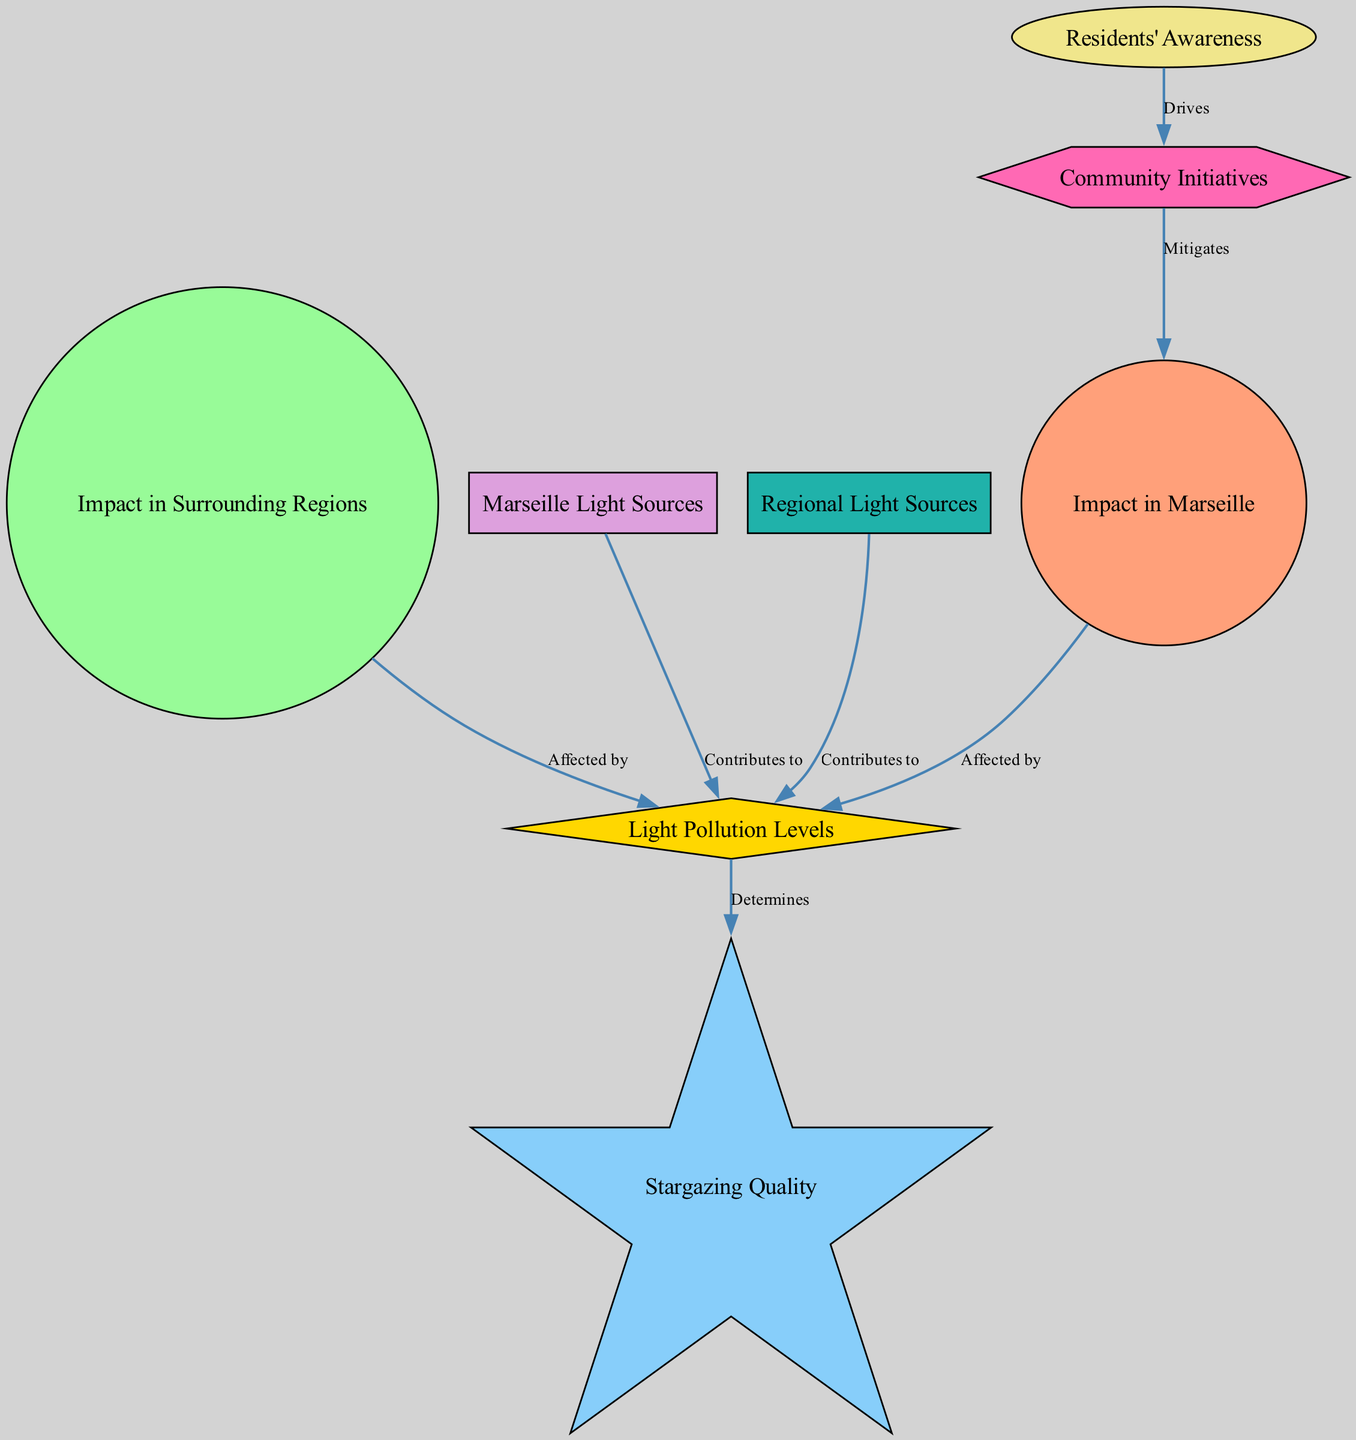What is the main impact of light pollution in Marseille? The diagram indicates that the main impact in Marseille is highlighted in the "Impact in Marseille" node. This node is connected to "Light Pollution Levels" node, indicating that the impact is due to the levels of light pollution present.
Answer: Impact in Marseille Which node signifies the contribution of Marseille's light sources to light pollution? The "Marseille Light Sources" node is connected to the "Light Pollution Levels" node, indicating that these sources contribute to the pollution levels affecting stargazing.
Answer: Marseille Light Sources What type of relationship exists between light pollution levels and stargazing quality? The diagram shows a directed edge from the "Light Pollution Levels" to the "Stargazing Quality" node, indicating a determining relationship where increased pollution negatively affects stargazing quality.
Answer: Determines How many community initiatives are associated with residents' awareness? The "Residents' Awareness" node is connected to the "Community Initiatives" node with an edge indicating that awareness drives these initiatives. The diagram suggests there is a singular connection.
Answer: 1 What color represents the stargazing quality in the diagram? The "Stargazing Quality" node is represented by a star shape and is colored in light blue, consistent with the color coding used throughout the diagram.
Answer: Light blue How do community initiatives impact the light pollution in Marseille? The diagram shows that "Community Initiatives" mitigate the "Impact in Marseille". Thus, these initiatives play a crucial role in reducing the negative effects of light pollution on stargazing in Marseille.
Answer: Mitigates Which node indicates the impact of light pollution in surrounding regions? The "Impact in Surrounding Regions" node signifies how light pollution affects areas around Marseille, linking it similarly to the "Light Pollution Levels" node.
Answer: Impact in Surrounding Regions What drives community initiatives according to the diagram? The edge from "Residents' Awareness" to "Community Initiatives" indicates that awareness among residents is the driving force for the community initiatives aimed at reducing light pollution.
Answer: Residents' Awareness 